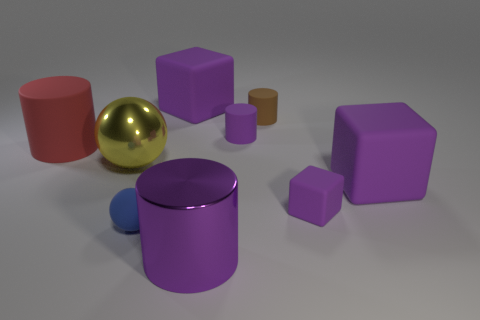Is the number of small rubber things behind the yellow sphere greater than the number of brown objects?
Offer a terse response. Yes. There is a large red thing; is it the same shape as the large purple metal thing that is in front of the red object?
Offer a very short reply. Yes. How many purple blocks have the same size as the yellow metal thing?
Make the answer very short. 2. What number of blocks are on the right side of the big purple thing in front of the large purple block that is to the right of the big purple shiny cylinder?
Give a very brief answer. 2. Are there an equal number of brown objects in front of the tiny blue ball and cylinders that are to the left of the shiny sphere?
Ensure brevity in your answer.  No. How many large red things have the same shape as the big purple metallic object?
Your answer should be very brief. 1. Are there any small purple things that have the same material as the tiny purple block?
Make the answer very short. Yes. There is a large metallic object that is the same color as the small cube; what is its shape?
Ensure brevity in your answer.  Cylinder. What number of large purple rubber objects are there?
Keep it short and to the point. 2. How many blocks are either big rubber things or blue matte things?
Ensure brevity in your answer.  2. 